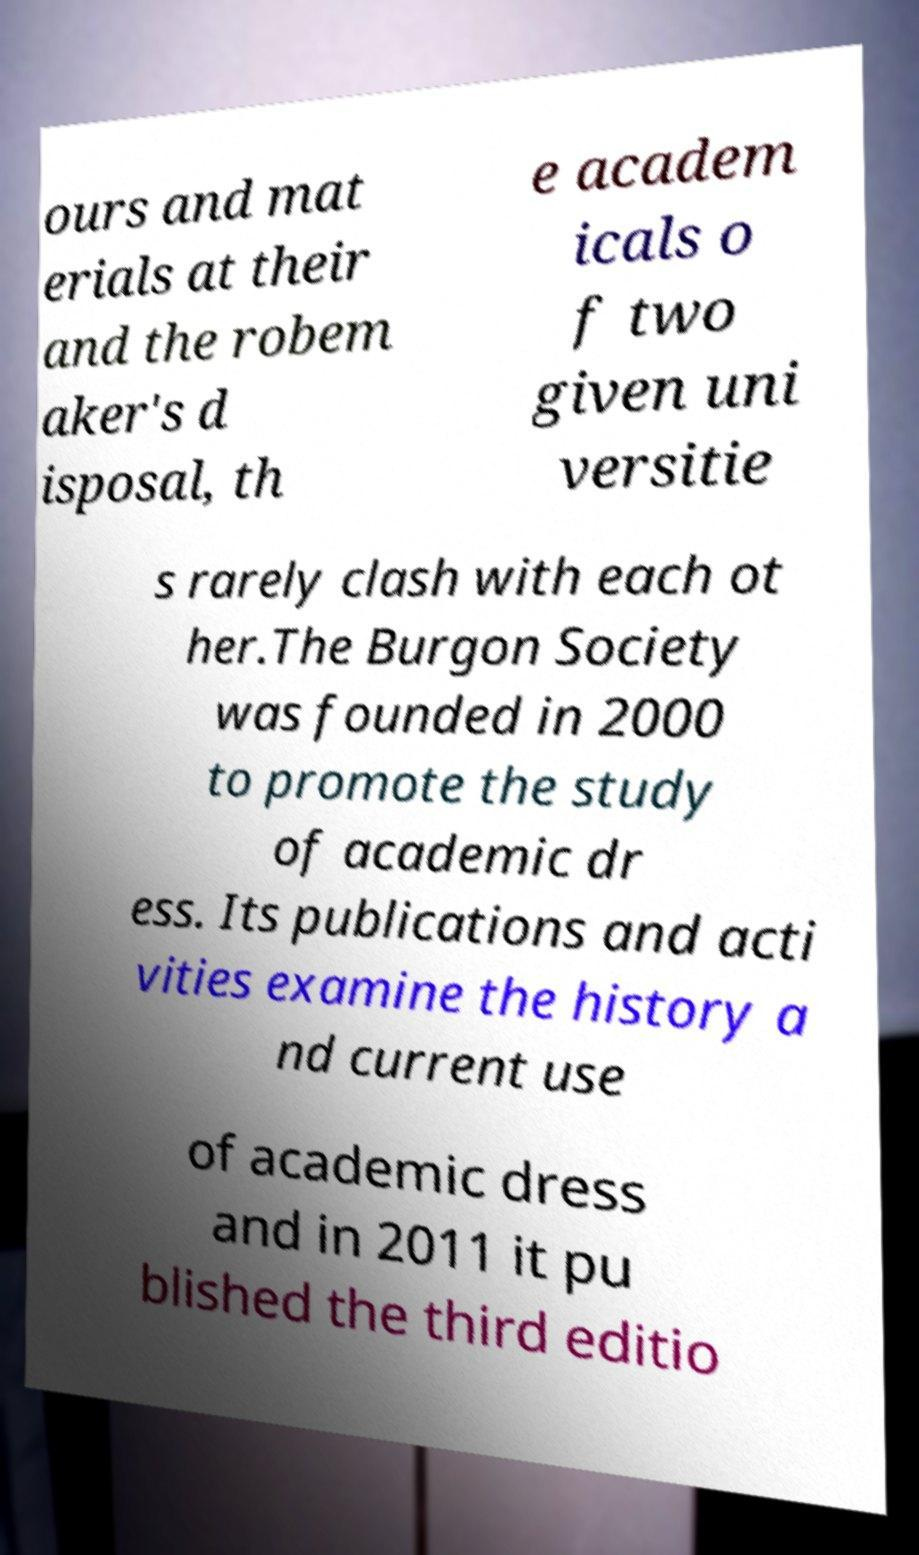Could you extract and type out the text from this image? ours and mat erials at their and the robem aker's d isposal, th e academ icals o f two given uni versitie s rarely clash with each ot her.The Burgon Society was founded in 2000 to promote the study of academic dr ess. Its publications and acti vities examine the history a nd current use of academic dress and in 2011 it pu blished the third editio 